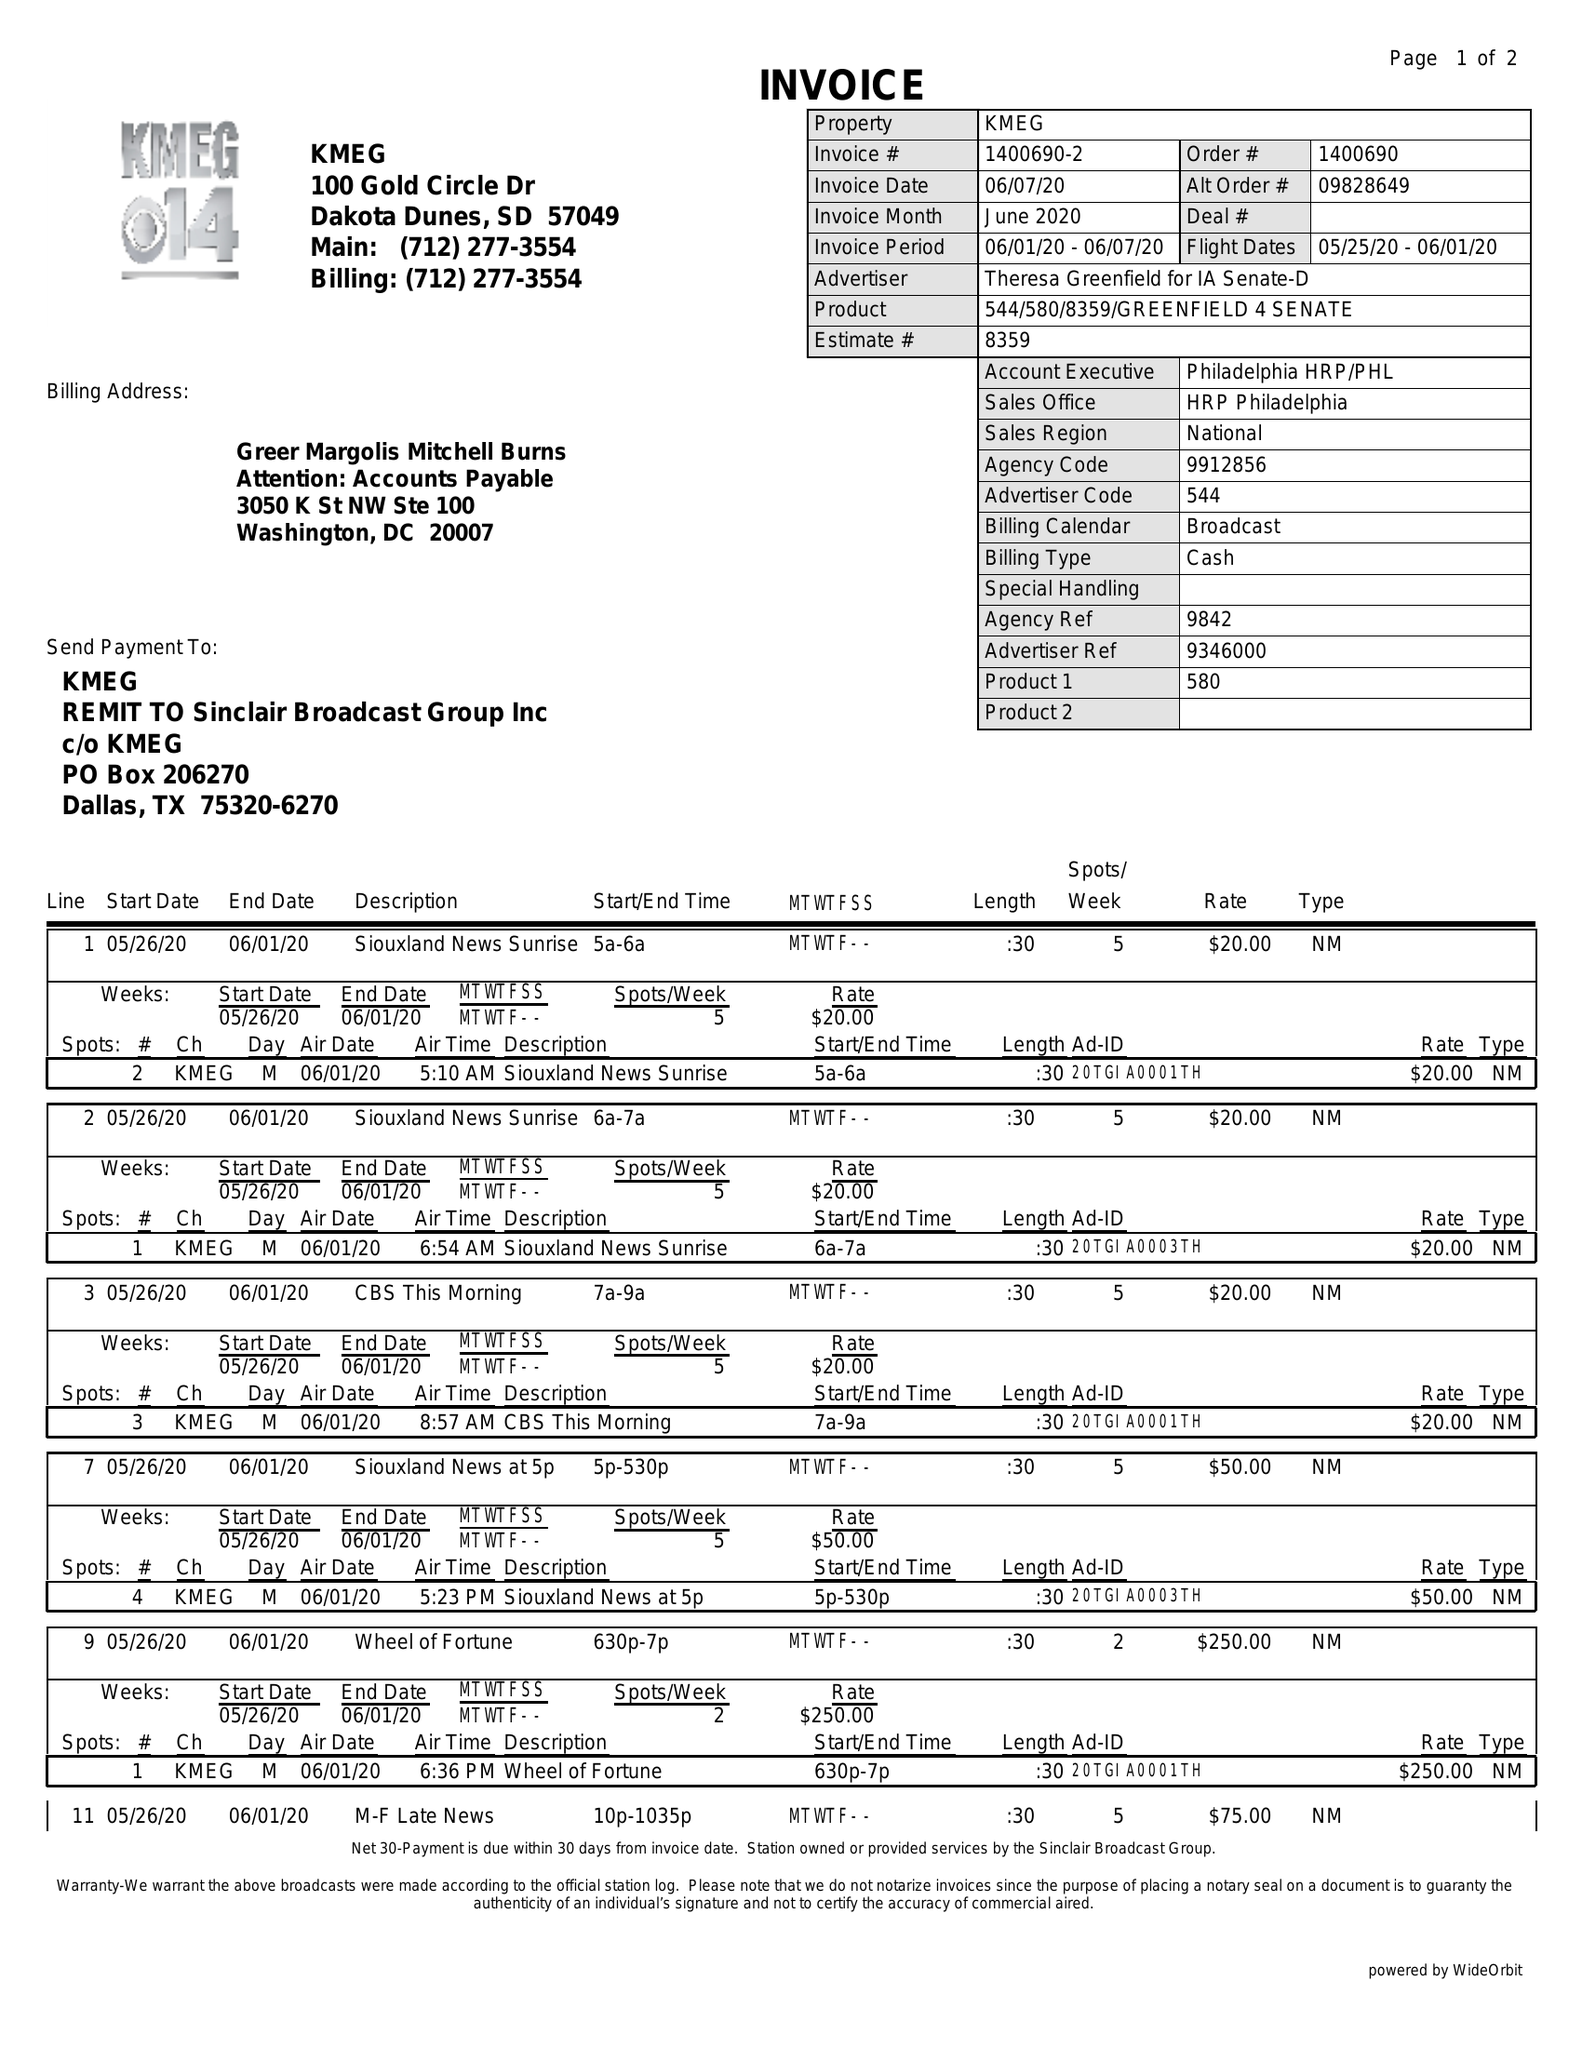What is the value for the flight_from?
Answer the question using a single word or phrase. 05/25/20 